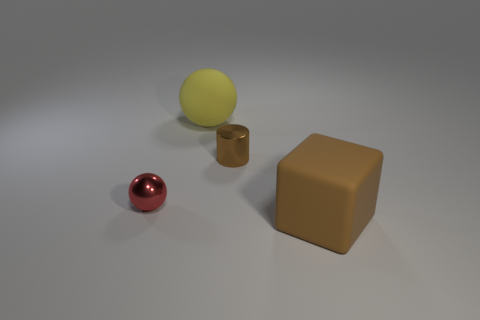Add 3 tiny metal objects. How many objects exist? 7 Subtract all cubes. How many objects are left? 3 Add 4 big brown cubes. How many big brown cubes are left? 5 Add 4 matte things. How many matte things exist? 6 Subtract 0 red cylinders. How many objects are left? 4 Subtract all tiny metallic objects. Subtract all brown shiny things. How many objects are left? 1 